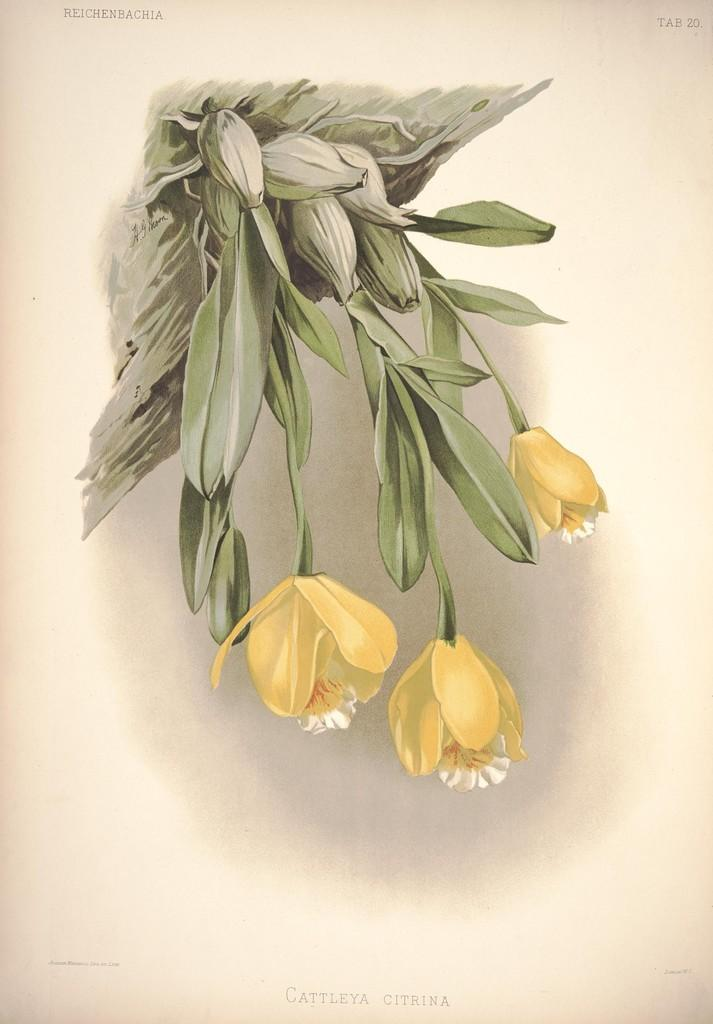What type of living organism is present in the image? There is a plant in the image. What features can be observed on the plant? The plant has flowers and buds. What type of dog is sitting on the manager's chin in the image? There is no dog or manager present in the image; it only features a plant with flowers and buds. 